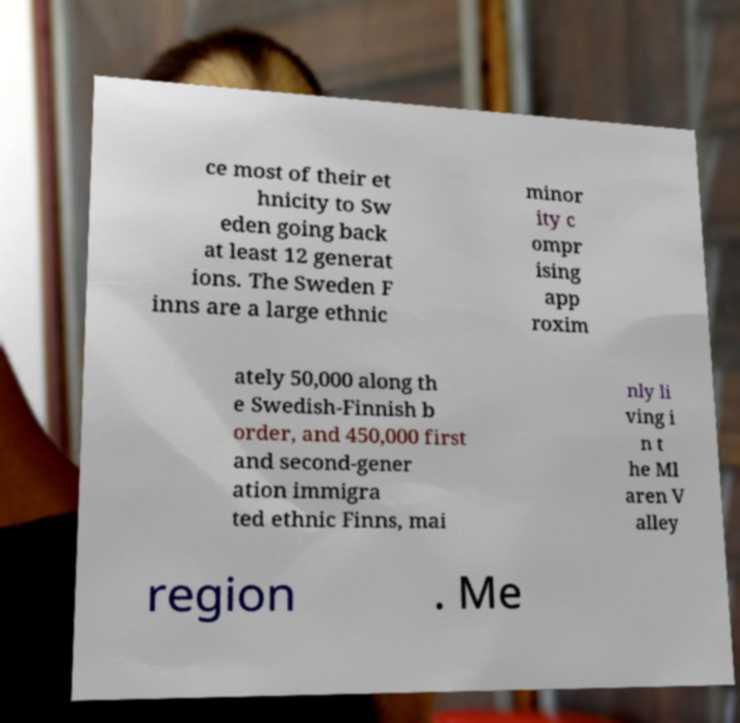What messages or text are displayed in this image? I need them in a readable, typed format. ce most of their et hnicity to Sw eden going back at least 12 generat ions. The Sweden F inns are a large ethnic minor ity c ompr ising app roxim ately 50,000 along th e Swedish-Finnish b order, and 450,000 first and second-gener ation immigra ted ethnic Finns, mai nly li ving i n t he Ml aren V alley region . Me 